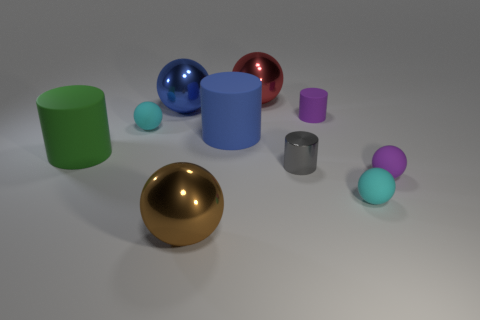Subtract 1 spheres. How many spheres are left? 5 Subtract all brown balls. How many balls are left? 5 Subtract all red balls. How many balls are left? 5 Subtract all green balls. Subtract all red blocks. How many balls are left? 6 Subtract all cylinders. How many objects are left? 6 Subtract 1 purple balls. How many objects are left? 9 Subtract all tiny red cylinders. Subtract all blue cylinders. How many objects are left? 9 Add 4 cyan balls. How many cyan balls are left? 6 Add 5 big metallic blocks. How many big metallic blocks exist? 5 